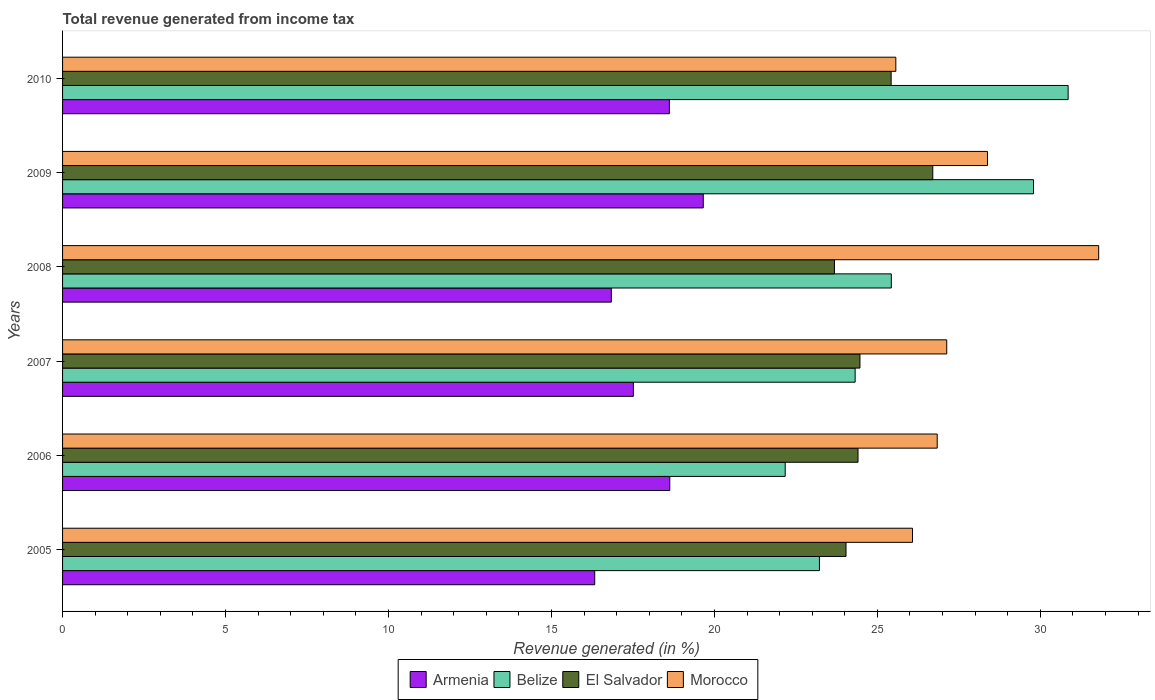How many groups of bars are there?
Offer a terse response. 6. Are the number of bars per tick equal to the number of legend labels?
Keep it short and to the point. Yes. How many bars are there on the 1st tick from the top?
Provide a short and direct response. 4. How many bars are there on the 6th tick from the bottom?
Make the answer very short. 4. In how many cases, is the number of bars for a given year not equal to the number of legend labels?
Make the answer very short. 0. What is the total revenue generated in Belize in 2006?
Make the answer very short. 22.17. Across all years, what is the maximum total revenue generated in Morocco?
Your answer should be very brief. 31.79. Across all years, what is the minimum total revenue generated in Armenia?
Your response must be concise. 16.33. In which year was the total revenue generated in El Salvador maximum?
Give a very brief answer. 2009. What is the total total revenue generated in Belize in the graph?
Provide a succinct answer. 155.78. What is the difference between the total revenue generated in Belize in 2006 and that in 2009?
Offer a terse response. -7.62. What is the difference between the total revenue generated in Morocco in 2009 and the total revenue generated in Belize in 2007?
Provide a succinct answer. 4.06. What is the average total revenue generated in El Salvador per year?
Keep it short and to the point. 24.79. In the year 2005, what is the difference between the total revenue generated in El Salvador and total revenue generated in Morocco?
Offer a very short reply. -2.04. In how many years, is the total revenue generated in El Salvador greater than 3 %?
Give a very brief answer. 6. What is the ratio of the total revenue generated in Belize in 2007 to that in 2010?
Your answer should be compact. 0.79. Is the difference between the total revenue generated in El Salvador in 2006 and 2007 greater than the difference between the total revenue generated in Morocco in 2006 and 2007?
Keep it short and to the point. Yes. What is the difference between the highest and the second highest total revenue generated in Morocco?
Your answer should be very brief. 3.41. What is the difference between the highest and the lowest total revenue generated in Morocco?
Give a very brief answer. 6.22. In how many years, is the total revenue generated in Morocco greater than the average total revenue generated in Morocco taken over all years?
Provide a succinct answer. 2. Is the sum of the total revenue generated in Armenia in 2008 and 2009 greater than the maximum total revenue generated in El Salvador across all years?
Your response must be concise. Yes. Is it the case that in every year, the sum of the total revenue generated in El Salvador and total revenue generated in Armenia is greater than the sum of total revenue generated in Belize and total revenue generated in Morocco?
Give a very brief answer. No. What does the 2nd bar from the top in 2008 represents?
Keep it short and to the point. El Salvador. What does the 4th bar from the bottom in 2009 represents?
Provide a succinct answer. Morocco. Is it the case that in every year, the sum of the total revenue generated in Morocco and total revenue generated in Belize is greater than the total revenue generated in El Salvador?
Ensure brevity in your answer.  Yes. How many years are there in the graph?
Give a very brief answer. 6. Does the graph contain grids?
Offer a very short reply. No. Where does the legend appear in the graph?
Give a very brief answer. Bottom center. How many legend labels are there?
Provide a short and direct response. 4. What is the title of the graph?
Make the answer very short. Total revenue generated from income tax. What is the label or title of the X-axis?
Ensure brevity in your answer.  Revenue generated (in %). What is the label or title of the Y-axis?
Your response must be concise. Years. What is the Revenue generated (in %) of Armenia in 2005?
Offer a terse response. 16.33. What is the Revenue generated (in %) in Belize in 2005?
Provide a succinct answer. 23.22. What is the Revenue generated (in %) in El Salvador in 2005?
Give a very brief answer. 24.04. What is the Revenue generated (in %) in Morocco in 2005?
Ensure brevity in your answer.  26.08. What is the Revenue generated (in %) in Armenia in 2006?
Provide a short and direct response. 18.63. What is the Revenue generated (in %) of Belize in 2006?
Give a very brief answer. 22.17. What is the Revenue generated (in %) of El Salvador in 2006?
Offer a terse response. 24.41. What is the Revenue generated (in %) in Morocco in 2006?
Give a very brief answer. 26.84. What is the Revenue generated (in %) of Armenia in 2007?
Your answer should be compact. 17.51. What is the Revenue generated (in %) in Belize in 2007?
Make the answer very short. 24.32. What is the Revenue generated (in %) of El Salvador in 2007?
Provide a short and direct response. 24.47. What is the Revenue generated (in %) in Morocco in 2007?
Keep it short and to the point. 27.13. What is the Revenue generated (in %) in Armenia in 2008?
Your answer should be very brief. 16.84. What is the Revenue generated (in %) of Belize in 2008?
Your response must be concise. 25.43. What is the Revenue generated (in %) of El Salvador in 2008?
Make the answer very short. 23.68. What is the Revenue generated (in %) in Morocco in 2008?
Your answer should be very brief. 31.79. What is the Revenue generated (in %) in Armenia in 2009?
Offer a terse response. 19.66. What is the Revenue generated (in %) in Belize in 2009?
Offer a very short reply. 29.79. What is the Revenue generated (in %) in El Salvador in 2009?
Ensure brevity in your answer.  26.7. What is the Revenue generated (in %) in Morocco in 2009?
Provide a succinct answer. 28.38. What is the Revenue generated (in %) of Armenia in 2010?
Give a very brief answer. 18.62. What is the Revenue generated (in %) of Belize in 2010?
Your response must be concise. 30.85. What is the Revenue generated (in %) in El Salvador in 2010?
Provide a succinct answer. 25.42. What is the Revenue generated (in %) of Morocco in 2010?
Give a very brief answer. 25.57. Across all years, what is the maximum Revenue generated (in %) of Armenia?
Ensure brevity in your answer.  19.66. Across all years, what is the maximum Revenue generated (in %) of Belize?
Provide a short and direct response. 30.85. Across all years, what is the maximum Revenue generated (in %) of El Salvador?
Your answer should be very brief. 26.7. Across all years, what is the maximum Revenue generated (in %) in Morocco?
Provide a short and direct response. 31.79. Across all years, what is the minimum Revenue generated (in %) in Armenia?
Ensure brevity in your answer.  16.33. Across all years, what is the minimum Revenue generated (in %) in Belize?
Your answer should be compact. 22.17. Across all years, what is the minimum Revenue generated (in %) of El Salvador?
Your answer should be very brief. 23.68. Across all years, what is the minimum Revenue generated (in %) in Morocco?
Ensure brevity in your answer.  25.57. What is the total Revenue generated (in %) of Armenia in the graph?
Ensure brevity in your answer.  107.59. What is the total Revenue generated (in %) in Belize in the graph?
Your answer should be compact. 155.78. What is the total Revenue generated (in %) in El Salvador in the graph?
Your answer should be very brief. 148.72. What is the total Revenue generated (in %) in Morocco in the graph?
Keep it short and to the point. 165.78. What is the difference between the Revenue generated (in %) of Armenia in 2005 and that in 2006?
Offer a very short reply. -2.3. What is the difference between the Revenue generated (in %) of Belize in 2005 and that in 2006?
Provide a succinct answer. 1.05. What is the difference between the Revenue generated (in %) in El Salvador in 2005 and that in 2006?
Give a very brief answer. -0.37. What is the difference between the Revenue generated (in %) of Morocco in 2005 and that in 2006?
Provide a succinct answer. -0.76. What is the difference between the Revenue generated (in %) in Armenia in 2005 and that in 2007?
Offer a terse response. -1.19. What is the difference between the Revenue generated (in %) of Belize in 2005 and that in 2007?
Provide a short and direct response. -1.1. What is the difference between the Revenue generated (in %) in El Salvador in 2005 and that in 2007?
Your response must be concise. -0.43. What is the difference between the Revenue generated (in %) in Morocco in 2005 and that in 2007?
Keep it short and to the point. -1.05. What is the difference between the Revenue generated (in %) of Armenia in 2005 and that in 2008?
Your response must be concise. -0.51. What is the difference between the Revenue generated (in %) of Belize in 2005 and that in 2008?
Provide a short and direct response. -2.21. What is the difference between the Revenue generated (in %) of El Salvador in 2005 and that in 2008?
Your response must be concise. 0.35. What is the difference between the Revenue generated (in %) of Morocco in 2005 and that in 2008?
Make the answer very short. -5.71. What is the difference between the Revenue generated (in %) of Armenia in 2005 and that in 2009?
Provide a succinct answer. -3.33. What is the difference between the Revenue generated (in %) of Belize in 2005 and that in 2009?
Offer a terse response. -6.57. What is the difference between the Revenue generated (in %) of El Salvador in 2005 and that in 2009?
Keep it short and to the point. -2.66. What is the difference between the Revenue generated (in %) in Morocco in 2005 and that in 2009?
Offer a terse response. -2.3. What is the difference between the Revenue generated (in %) in Armenia in 2005 and that in 2010?
Give a very brief answer. -2.29. What is the difference between the Revenue generated (in %) in Belize in 2005 and that in 2010?
Ensure brevity in your answer.  -7.63. What is the difference between the Revenue generated (in %) in El Salvador in 2005 and that in 2010?
Provide a succinct answer. -1.38. What is the difference between the Revenue generated (in %) in Morocco in 2005 and that in 2010?
Provide a succinct answer. 0.51. What is the difference between the Revenue generated (in %) of Armenia in 2006 and that in 2007?
Your response must be concise. 1.12. What is the difference between the Revenue generated (in %) in Belize in 2006 and that in 2007?
Provide a succinct answer. -2.15. What is the difference between the Revenue generated (in %) in El Salvador in 2006 and that in 2007?
Keep it short and to the point. -0.06. What is the difference between the Revenue generated (in %) in Morocco in 2006 and that in 2007?
Keep it short and to the point. -0.29. What is the difference between the Revenue generated (in %) of Armenia in 2006 and that in 2008?
Provide a short and direct response. 1.79. What is the difference between the Revenue generated (in %) of Belize in 2006 and that in 2008?
Offer a terse response. -3.26. What is the difference between the Revenue generated (in %) of El Salvador in 2006 and that in 2008?
Your answer should be very brief. 0.72. What is the difference between the Revenue generated (in %) of Morocco in 2006 and that in 2008?
Your answer should be compact. -4.95. What is the difference between the Revenue generated (in %) of Armenia in 2006 and that in 2009?
Give a very brief answer. -1.03. What is the difference between the Revenue generated (in %) of Belize in 2006 and that in 2009?
Offer a very short reply. -7.62. What is the difference between the Revenue generated (in %) in El Salvador in 2006 and that in 2009?
Provide a short and direct response. -2.29. What is the difference between the Revenue generated (in %) of Morocco in 2006 and that in 2009?
Keep it short and to the point. -1.54. What is the difference between the Revenue generated (in %) in Armenia in 2006 and that in 2010?
Your answer should be compact. 0.01. What is the difference between the Revenue generated (in %) of Belize in 2006 and that in 2010?
Your response must be concise. -8.68. What is the difference between the Revenue generated (in %) in El Salvador in 2006 and that in 2010?
Provide a succinct answer. -1.02. What is the difference between the Revenue generated (in %) of Morocco in 2006 and that in 2010?
Your answer should be very brief. 1.27. What is the difference between the Revenue generated (in %) of Armenia in 2007 and that in 2008?
Ensure brevity in your answer.  0.68. What is the difference between the Revenue generated (in %) in Belize in 2007 and that in 2008?
Give a very brief answer. -1.11. What is the difference between the Revenue generated (in %) of El Salvador in 2007 and that in 2008?
Your response must be concise. 0.78. What is the difference between the Revenue generated (in %) of Morocco in 2007 and that in 2008?
Make the answer very short. -4.66. What is the difference between the Revenue generated (in %) in Armenia in 2007 and that in 2009?
Offer a very short reply. -2.14. What is the difference between the Revenue generated (in %) of Belize in 2007 and that in 2009?
Keep it short and to the point. -5.47. What is the difference between the Revenue generated (in %) in El Salvador in 2007 and that in 2009?
Your answer should be very brief. -2.23. What is the difference between the Revenue generated (in %) of Morocco in 2007 and that in 2009?
Your answer should be very brief. -1.25. What is the difference between the Revenue generated (in %) in Armenia in 2007 and that in 2010?
Offer a very short reply. -1.1. What is the difference between the Revenue generated (in %) in Belize in 2007 and that in 2010?
Offer a very short reply. -6.53. What is the difference between the Revenue generated (in %) in El Salvador in 2007 and that in 2010?
Offer a very short reply. -0.96. What is the difference between the Revenue generated (in %) of Morocco in 2007 and that in 2010?
Your response must be concise. 1.56. What is the difference between the Revenue generated (in %) in Armenia in 2008 and that in 2009?
Offer a very short reply. -2.82. What is the difference between the Revenue generated (in %) in Belize in 2008 and that in 2009?
Provide a succinct answer. -4.36. What is the difference between the Revenue generated (in %) in El Salvador in 2008 and that in 2009?
Keep it short and to the point. -3.02. What is the difference between the Revenue generated (in %) in Morocco in 2008 and that in 2009?
Your response must be concise. 3.41. What is the difference between the Revenue generated (in %) in Armenia in 2008 and that in 2010?
Make the answer very short. -1.78. What is the difference between the Revenue generated (in %) in Belize in 2008 and that in 2010?
Offer a terse response. -5.43. What is the difference between the Revenue generated (in %) in El Salvador in 2008 and that in 2010?
Your response must be concise. -1.74. What is the difference between the Revenue generated (in %) in Morocco in 2008 and that in 2010?
Provide a succinct answer. 6.22. What is the difference between the Revenue generated (in %) of Armenia in 2009 and that in 2010?
Offer a terse response. 1.04. What is the difference between the Revenue generated (in %) in Belize in 2009 and that in 2010?
Provide a succinct answer. -1.06. What is the difference between the Revenue generated (in %) of El Salvador in 2009 and that in 2010?
Make the answer very short. 1.28. What is the difference between the Revenue generated (in %) of Morocco in 2009 and that in 2010?
Your answer should be very brief. 2.81. What is the difference between the Revenue generated (in %) in Armenia in 2005 and the Revenue generated (in %) in Belize in 2006?
Ensure brevity in your answer.  -5.84. What is the difference between the Revenue generated (in %) in Armenia in 2005 and the Revenue generated (in %) in El Salvador in 2006?
Ensure brevity in your answer.  -8.08. What is the difference between the Revenue generated (in %) of Armenia in 2005 and the Revenue generated (in %) of Morocco in 2006?
Your response must be concise. -10.51. What is the difference between the Revenue generated (in %) of Belize in 2005 and the Revenue generated (in %) of El Salvador in 2006?
Your answer should be very brief. -1.18. What is the difference between the Revenue generated (in %) in Belize in 2005 and the Revenue generated (in %) in Morocco in 2006?
Offer a very short reply. -3.61. What is the difference between the Revenue generated (in %) of El Salvador in 2005 and the Revenue generated (in %) of Morocco in 2006?
Provide a succinct answer. -2.8. What is the difference between the Revenue generated (in %) in Armenia in 2005 and the Revenue generated (in %) in Belize in 2007?
Ensure brevity in your answer.  -7.99. What is the difference between the Revenue generated (in %) of Armenia in 2005 and the Revenue generated (in %) of El Salvador in 2007?
Ensure brevity in your answer.  -8.14. What is the difference between the Revenue generated (in %) of Armenia in 2005 and the Revenue generated (in %) of Morocco in 2007?
Keep it short and to the point. -10.8. What is the difference between the Revenue generated (in %) in Belize in 2005 and the Revenue generated (in %) in El Salvador in 2007?
Offer a very short reply. -1.24. What is the difference between the Revenue generated (in %) of Belize in 2005 and the Revenue generated (in %) of Morocco in 2007?
Ensure brevity in your answer.  -3.91. What is the difference between the Revenue generated (in %) of El Salvador in 2005 and the Revenue generated (in %) of Morocco in 2007?
Give a very brief answer. -3.09. What is the difference between the Revenue generated (in %) of Armenia in 2005 and the Revenue generated (in %) of Belize in 2008?
Provide a short and direct response. -9.1. What is the difference between the Revenue generated (in %) in Armenia in 2005 and the Revenue generated (in %) in El Salvador in 2008?
Your answer should be very brief. -7.36. What is the difference between the Revenue generated (in %) of Armenia in 2005 and the Revenue generated (in %) of Morocco in 2008?
Ensure brevity in your answer.  -15.46. What is the difference between the Revenue generated (in %) of Belize in 2005 and the Revenue generated (in %) of El Salvador in 2008?
Provide a succinct answer. -0.46. What is the difference between the Revenue generated (in %) in Belize in 2005 and the Revenue generated (in %) in Morocco in 2008?
Offer a terse response. -8.57. What is the difference between the Revenue generated (in %) in El Salvador in 2005 and the Revenue generated (in %) in Morocco in 2008?
Your response must be concise. -7.75. What is the difference between the Revenue generated (in %) of Armenia in 2005 and the Revenue generated (in %) of Belize in 2009?
Keep it short and to the point. -13.46. What is the difference between the Revenue generated (in %) of Armenia in 2005 and the Revenue generated (in %) of El Salvador in 2009?
Your response must be concise. -10.37. What is the difference between the Revenue generated (in %) of Armenia in 2005 and the Revenue generated (in %) of Morocco in 2009?
Make the answer very short. -12.05. What is the difference between the Revenue generated (in %) in Belize in 2005 and the Revenue generated (in %) in El Salvador in 2009?
Your answer should be very brief. -3.48. What is the difference between the Revenue generated (in %) in Belize in 2005 and the Revenue generated (in %) in Morocco in 2009?
Make the answer very short. -5.16. What is the difference between the Revenue generated (in %) in El Salvador in 2005 and the Revenue generated (in %) in Morocco in 2009?
Give a very brief answer. -4.34. What is the difference between the Revenue generated (in %) in Armenia in 2005 and the Revenue generated (in %) in Belize in 2010?
Your answer should be compact. -14.53. What is the difference between the Revenue generated (in %) in Armenia in 2005 and the Revenue generated (in %) in El Salvador in 2010?
Offer a terse response. -9.1. What is the difference between the Revenue generated (in %) in Armenia in 2005 and the Revenue generated (in %) in Morocco in 2010?
Make the answer very short. -9.24. What is the difference between the Revenue generated (in %) in Belize in 2005 and the Revenue generated (in %) in El Salvador in 2010?
Make the answer very short. -2.2. What is the difference between the Revenue generated (in %) in Belize in 2005 and the Revenue generated (in %) in Morocco in 2010?
Make the answer very short. -2.34. What is the difference between the Revenue generated (in %) of El Salvador in 2005 and the Revenue generated (in %) of Morocco in 2010?
Your response must be concise. -1.53. What is the difference between the Revenue generated (in %) in Armenia in 2006 and the Revenue generated (in %) in Belize in 2007?
Your answer should be very brief. -5.69. What is the difference between the Revenue generated (in %) of Armenia in 2006 and the Revenue generated (in %) of El Salvador in 2007?
Provide a short and direct response. -5.84. What is the difference between the Revenue generated (in %) in Armenia in 2006 and the Revenue generated (in %) in Morocco in 2007?
Provide a short and direct response. -8.5. What is the difference between the Revenue generated (in %) in Belize in 2006 and the Revenue generated (in %) in El Salvador in 2007?
Provide a short and direct response. -2.29. What is the difference between the Revenue generated (in %) of Belize in 2006 and the Revenue generated (in %) of Morocco in 2007?
Give a very brief answer. -4.96. What is the difference between the Revenue generated (in %) in El Salvador in 2006 and the Revenue generated (in %) in Morocco in 2007?
Make the answer very short. -2.72. What is the difference between the Revenue generated (in %) in Armenia in 2006 and the Revenue generated (in %) in Belize in 2008?
Your response must be concise. -6.8. What is the difference between the Revenue generated (in %) of Armenia in 2006 and the Revenue generated (in %) of El Salvador in 2008?
Your answer should be very brief. -5.05. What is the difference between the Revenue generated (in %) of Armenia in 2006 and the Revenue generated (in %) of Morocco in 2008?
Your answer should be very brief. -13.16. What is the difference between the Revenue generated (in %) in Belize in 2006 and the Revenue generated (in %) in El Salvador in 2008?
Keep it short and to the point. -1.51. What is the difference between the Revenue generated (in %) in Belize in 2006 and the Revenue generated (in %) in Morocco in 2008?
Offer a very short reply. -9.62. What is the difference between the Revenue generated (in %) in El Salvador in 2006 and the Revenue generated (in %) in Morocco in 2008?
Your answer should be compact. -7.38. What is the difference between the Revenue generated (in %) in Armenia in 2006 and the Revenue generated (in %) in Belize in 2009?
Provide a short and direct response. -11.16. What is the difference between the Revenue generated (in %) of Armenia in 2006 and the Revenue generated (in %) of El Salvador in 2009?
Offer a very short reply. -8.07. What is the difference between the Revenue generated (in %) of Armenia in 2006 and the Revenue generated (in %) of Morocco in 2009?
Your response must be concise. -9.75. What is the difference between the Revenue generated (in %) in Belize in 2006 and the Revenue generated (in %) in El Salvador in 2009?
Offer a very short reply. -4.53. What is the difference between the Revenue generated (in %) of Belize in 2006 and the Revenue generated (in %) of Morocco in 2009?
Ensure brevity in your answer.  -6.21. What is the difference between the Revenue generated (in %) of El Salvador in 2006 and the Revenue generated (in %) of Morocco in 2009?
Your response must be concise. -3.97. What is the difference between the Revenue generated (in %) of Armenia in 2006 and the Revenue generated (in %) of Belize in 2010?
Your answer should be very brief. -12.22. What is the difference between the Revenue generated (in %) in Armenia in 2006 and the Revenue generated (in %) in El Salvador in 2010?
Give a very brief answer. -6.79. What is the difference between the Revenue generated (in %) in Armenia in 2006 and the Revenue generated (in %) in Morocco in 2010?
Your answer should be compact. -6.94. What is the difference between the Revenue generated (in %) in Belize in 2006 and the Revenue generated (in %) in El Salvador in 2010?
Offer a terse response. -3.25. What is the difference between the Revenue generated (in %) of Belize in 2006 and the Revenue generated (in %) of Morocco in 2010?
Offer a very short reply. -3.39. What is the difference between the Revenue generated (in %) in El Salvador in 2006 and the Revenue generated (in %) in Morocco in 2010?
Offer a terse response. -1.16. What is the difference between the Revenue generated (in %) in Armenia in 2007 and the Revenue generated (in %) in Belize in 2008?
Your response must be concise. -7.91. What is the difference between the Revenue generated (in %) of Armenia in 2007 and the Revenue generated (in %) of El Salvador in 2008?
Provide a short and direct response. -6.17. What is the difference between the Revenue generated (in %) in Armenia in 2007 and the Revenue generated (in %) in Morocco in 2008?
Your answer should be very brief. -14.28. What is the difference between the Revenue generated (in %) of Belize in 2007 and the Revenue generated (in %) of El Salvador in 2008?
Keep it short and to the point. 0.64. What is the difference between the Revenue generated (in %) of Belize in 2007 and the Revenue generated (in %) of Morocco in 2008?
Your answer should be very brief. -7.47. What is the difference between the Revenue generated (in %) of El Salvador in 2007 and the Revenue generated (in %) of Morocco in 2008?
Provide a short and direct response. -7.32. What is the difference between the Revenue generated (in %) in Armenia in 2007 and the Revenue generated (in %) in Belize in 2009?
Your answer should be very brief. -12.28. What is the difference between the Revenue generated (in %) in Armenia in 2007 and the Revenue generated (in %) in El Salvador in 2009?
Keep it short and to the point. -9.19. What is the difference between the Revenue generated (in %) in Armenia in 2007 and the Revenue generated (in %) in Morocco in 2009?
Provide a short and direct response. -10.86. What is the difference between the Revenue generated (in %) in Belize in 2007 and the Revenue generated (in %) in El Salvador in 2009?
Ensure brevity in your answer.  -2.38. What is the difference between the Revenue generated (in %) in Belize in 2007 and the Revenue generated (in %) in Morocco in 2009?
Offer a very short reply. -4.06. What is the difference between the Revenue generated (in %) in El Salvador in 2007 and the Revenue generated (in %) in Morocco in 2009?
Your answer should be compact. -3.91. What is the difference between the Revenue generated (in %) of Armenia in 2007 and the Revenue generated (in %) of Belize in 2010?
Provide a short and direct response. -13.34. What is the difference between the Revenue generated (in %) of Armenia in 2007 and the Revenue generated (in %) of El Salvador in 2010?
Provide a short and direct response. -7.91. What is the difference between the Revenue generated (in %) of Armenia in 2007 and the Revenue generated (in %) of Morocco in 2010?
Your answer should be compact. -8.05. What is the difference between the Revenue generated (in %) in Belize in 2007 and the Revenue generated (in %) in El Salvador in 2010?
Keep it short and to the point. -1.1. What is the difference between the Revenue generated (in %) of Belize in 2007 and the Revenue generated (in %) of Morocco in 2010?
Your response must be concise. -1.25. What is the difference between the Revenue generated (in %) in El Salvador in 2007 and the Revenue generated (in %) in Morocco in 2010?
Make the answer very short. -1.1. What is the difference between the Revenue generated (in %) of Armenia in 2008 and the Revenue generated (in %) of Belize in 2009?
Offer a terse response. -12.95. What is the difference between the Revenue generated (in %) of Armenia in 2008 and the Revenue generated (in %) of El Salvador in 2009?
Your answer should be compact. -9.86. What is the difference between the Revenue generated (in %) in Armenia in 2008 and the Revenue generated (in %) in Morocco in 2009?
Give a very brief answer. -11.54. What is the difference between the Revenue generated (in %) in Belize in 2008 and the Revenue generated (in %) in El Salvador in 2009?
Keep it short and to the point. -1.27. What is the difference between the Revenue generated (in %) in Belize in 2008 and the Revenue generated (in %) in Morocco in 2009?
Give a very brief answer. -2.95. What is the difference between the Revenue generated (in %) of El Salvador in 2008 and the Revenue generated (in %) of Morocco in 2009?
Ensure brevity in your answer.  -4.7. What is the difference between the Revenue generated (in %) in Armenia in 2008 and the Revenue generated (in %) in Belize in 2010?
Provide a short and direct response. -14.02. What is the difference between the Revenue generated (in %) in Armenia in 2008 and the Revenue generated (in %) in El Salvador in 2010?
Keep it short and to the point. -8.59. What is the difference between the Revenue generated (in %) in Armenia in 2008 and the Revenue generated (in %) in Morocco in 2010?
Ensure brevity in your answer.  -8.73. What is the difference between the Revenue generated (in %) in Belize in 2008 and the Revenue generated (in %) in El Salvador in 2010?
Make the answer very short. 0.01. What is the difference between the Revenue generated (in %) of Belize in 2008 and the Revenue generated (in %) of Morocco in 2010?
Your answer should be very brief. -0.14. What is the difference between the Revenue generated (in %) in El Salvador in 2008 and the Revenue generated (in %) in Morocco in 2010?
Your response must be concise. -1.88. What is the difference between the Revenue generated (in %) in Armenia in 2009 and the Revenue generated (in %) in Belize in 2010?
Provide a succinct answer. -11.19. What is the difference between the Revenue generated (in %) in Armenia in 2009 and the Revenue generated (in %) in El Salvador in 2010?
Ensure brevity in your answer.  -5.76. What is the difference between the Revenue generated (in %) of Armenia in 2009 and the Revenue generated (in %) of Morocco in 2010?
Your answer should be very brief. -5.91. What is the difference between the Revenue generated (in %) of Belize in 2009 and the Revenue generated (in %) of El Salvador in 2010?
Offer a very short reply. 4.37. What is the difference between the Revenue generated (in %) in Belize in 2009 and the Revenue generated (in %) in Morocco in 2010?
Ensure brevity in your answer.  4.22. What is the difference between the Revenue generated (in %) of El Salvador in 2009 and the Revenue generated (in %) of Morocco in 2010?
Give a very brief answer. 1.13. What is the average Revenue generated (in %) of Armenia per year?
Your response must be concise. 17.93. What is the average Revenue generated (in %) of Belize per year?
Keep it short and to the point. 25.96. What is the average Revenue generated (in %) of El Salvador per year?
Your response must be concise. 24.79. What is the average Revenue generated (in %) of Morocco per year?
Offer a terse response. 27.63. In the year 2005, what is the difference between the Revenue generated (in %) of Armenia and Revenue generated (in %) of Belize?
Give a very brief answer. -6.89. In the year 2005, what is the difference between the Revenue generated (in %) of Armenia and Revenue generated (in %) of El Salvador?
Keep it short and to the point. -7.71. In the year 2005, what is the difference between the Revenue generated (in %) in Armenia and Revenue generated (in %) in Morocco?
Ensure brevity in your answer.  -9.75. In the year 2005, what is the difference between the Revenue generated (in %) of Belize and Revenue generated (in %) of El Salvador?
Offer a very short reply. -0.82. In the year 2005, what is the difference between the Revenue generated (in %) of Belize and Revenue generated (in %) of Morocco?
Make the answer very short. -2.86. In the year 2005, what is the difference between the Revenue generated (in %) of El Salvador and Revenue generated (in %) of Morocco?
Provide a short and direct response. -2.04. In the year 2006, what is the difference between the Revenue generated (in %) in Armenia and Revenue generated (in %) in Belize?
Your answer should be compact. -3.54. In the year 2006, what is the difference between the Revenue generated (in %) of Armenia and Revenue generated (in %) of El Salvador?
Keep it short and to the point. -5.78. In the year 2006, what is the difference between the Revenue generated (in %) in Armenia and Revenue generated (in %) in Morocco?
Provide a succinct answer. -8.21. In the year 2006, what is the difference between the Revenue generated (in %) in Belize and Revenue generated (in %) in El Salvador?
Your answer should be compact. -2.23. In the year 2006, what is the difference between the Revenue generated (in %) of Belize and Revenue generated (in %) of Morocco?
Give a very brief answer. -4.66. In the year 2006, what is the difference between the Revenue generated (in %) of El Salvador and Revenue generated (in %) of Morocco?
Make the answer very short. -2.43. In the year 2007, what is the difference between the Revenue generated (in %) of Armenia and Revenue generated (in %) of Belize?
Give a very brief answer. -6.8. In the year 2007, what is the difference between the Revenue generated (in %) in Armenia and Revenue generated (in %) in El Salvador?
Provide a short and direct response. -6.95. In the year 2007, what is the difference between the Revenue generated (in %) of Armenia and Revenue generated (in %) of Morocco?
Provide a short and direct response. -9.61. In the year 2007, what is the difference between the Revenue generated (in %) in Belize and Revenue generated (in %) in El Salvador?
Offer a very short reply. -0.15. In the year 2007, what is the difference between the Revenue generated (in %) in Belize and Revenue generated (in %) in Morocco?
Give a very brief answer. -2.81. In the year 2007, what is the difference between the Revenue generated (in %) of El Salvador and Revenue generated (in %) of Morocco?
Provide a succinct answer. -2.66. In the year 2008, what is the difference between the Revenue generated (in %) of Armenia and Revenue generated (in %) of Belize?
Provide a short and direct response. -8.59. In the year 2008, what is the difference between the Revenue generated (in %) in Armenia and Revenue generated (in %) in El Salvador?
Ensure brevity in your answer.  -6.85. In the year 2008, what is the difference between the Revenue generated (in %) of Armenia and Revenue generated (in %) of Morocco?
Keep it short and to the point. -14.95. In the year 2008, what is the difference between the Revenue generated (in %) in Belize and Revenue generated (in %) in El Salvador?
Your response must be concise. 1.74. In the year 2008, what is the difference between the Revenue generated (in %) of Belize and Revenue generated (in %) of Morocco?
Keep it short and to the point. -6.36. In the year 2008, what is the difference between the Revenue generated (in %) of El Salvador and Revenue generated (in %) of Morocco?
Offer a very short reply. -8.11. In the year 2009, what is the difference between the Revenue generated (in %) in Armenia and Revenue generated (in %) in Belize?
Your response must be concise. -10.13. In the year 2009, what is the difference between the Revenue generated (in %) of Armenia and Revenue generated (in %) of El Salvador?
Make the answer very short. -7.04. In the year 2009, what is the difference between the Revenue generated (in %) of Armenia and Revenue generated (in %) of Morocco?
Offer a terse response. -8.72. In the year 2009, what is the difference between the Revenue generated (in %) of Belize and Revenue generated (in %) of El Salvador?
Your answer should be very brief. 3.09. In the year 2009, what is the difference between the Revenue generated (in %) of Belize and Revenue generated (in %) of Morocco?
Your response must be concise. 1.41. In the year 2009, what is the difference between the Revenue generated (in %) in El Salvador and Revenue generated (in %) in Morocco?
Offer a very short reply. -1.68. In the year 2010, what is the difference between the Revenue generated (in %) in Armenia and Revenue generated (in %) in Belize?
Your response must be concise. -12.23. In the year 2010, what is the difference between the Revenue generated (in %) in Armenia and Revenue generated (in %) in El Salvador?
Your response must be concise. -6.8. In the year 2010, what is the difference between the Revenue generated (in %) in Armenia and Revenue generated (in %) in Morocco?
Provide a succinct answer. -6.95. In the year 2010, what is the difference between the Revenue generated (in %) of Belize and Revenue generated (in %) of El Salvador?
Keep it short and to the point. 5.43. In the year 2010, what is the difference between the Revenue generated (in %) in Belize and Revenue generated (in %) in Morocco?
Offer a very short reply. 5.29. In the year 2010, what is the difference between the Revenue generated (in %) of El Salvador and Revenue generated (in %) of Morocco?
Provide a short and direct response. -0.14. What is the ratio of the Revenue generated (in %) in Armenia in 2005 to that in 2006?
Provide a short and direct response. 0.88. What is the ratio of the Revenue generated (in %) of Belize in 2005 to that in 2006?
Ensure brevity in your answer.  1.05. What is the ratio of the Revenue generated (in %) of El Salvador in 2005 to that in 2006?
Offer a terse response. 0.98. What is the ratio of the Revenue generated (in %) in Morocco in 2005 to that in 2006?
Your response must be concise. 0.97. What is the ratio of the Revenue generated (in %) of Armenia in 2005 to that in 2007?
Give a very brief answer. 0.93. What is the ratio of the Revenue generated (in %) of Belize in 2005 to that in 2007?
Offer a very short reply. 0.95. What is the ratio of the Revenue generated (in %) in El Salvador in 2005 to that in 2007?
Ensure brevity in your answer.  0.98. What is the ratio of the Revenue generated (in %) in Morocco in 2005 to that in 2007?
Your answer should be compact. 0.96. What is the ratio of the Revenue generated (in %) of Armenia in 2005 to that in 2008?
Your answer should be very brief. 0.97. What is the ratio of the Revenue generated (in %) in Belize in 2005 to that in 2008?
Keep it short and to the point. 0.91. What is the ratio of the Revenue generated (in %) in Morocco in 2005 to that in 2008?
Ensure brevity in your answer.  0.82. What is the ratio of the Revenue generated (in %) of Armenia in 2005 to that in 2009?
Give a very brief answer. 0.83. What is the ratio of the Revenue generated (in %) in Belize in 2005 to that in 2009?
Offer a very short reply. 0.78. What is the ratio of the Revenue generated (in %) of El Salvador in 2005 to that in 2009?
Offer a terse response. 0.9. What is the ratio of the Revenue generated (in %) in Morocco in 2005 to that in 2009?
Provide a succinct answer. 0.92. What is the ratio of the Revenue generated (in %) in Armenia in 2005 to that in 2010?
Your response must be concise. 0.88. What is the ratio of the Revenue generated (in %) of Belize in 2005 to that in 2010?
Your answer should be compact. 0.75. What is the ratio of the Revenue generated (in %) in El Salvador in 2005 to that in 2010?
Your answer should be very brief. 0.95. What is the ratio of the Revenue generated (in %) of Morocco in 2005 to that in 2010?
Your answer should be very brief. 1.02. What is the ratio of the Revenue generated (in %) of Armenia in 2006 to that in 2007?
Make the answer very short. 1.06. What is the ratio of the Revenue generated (in %) of Belize in 2006 to that in 2007?
Your response must be concise. 0.91. What is the ratio of the Revenue generated (in %) of El Salvador in 2006 to that in 2007?
Your answer should be very brief. 1. What is the ratio of the Revenue generated (in %) of Armenia in 2006 to that in 2008?
Give a very brief answer. 1.11. What is the ratio of the Revenue generated (in %) in Belize in 2006 to that in 2008?
Make the answer very short. 0.87. What is the ratio of the Revenue generated (in %) of El Salvador in 2006 to that in 2008?
Make the answer very short. 1.03. What is the ratio of the Revenue generated (in %) of Morocco in 2006 to that in 2008?
Ensure brevity in your answer.  0.84. What is the ratio of the Revenue generated (in %) of Armenia in 2006 to that in 2009?
Provide a succinct answer. 0.95. What is the ratio of the Revenue generated (in %) in Belize in 2006 to that in 2009?
Give a very brief answer. 0.74. What is the ratio of the Revenue generated (in %) in El Salvador in 2006 to that in 2009?
Ensure brevity in your answer.  0.91. What is the ratio of the Revenue generated (in %) of Morocco in 2006 to that in 2009?
Offer a terse response. 0.95. What is the ratio of the Revenue generated (in %) in Armenia in 2006 to that in 2010?
Ensure brevity in your answer.  1. What is the ratio of the Revenue generated (in %) in Belize in 2006 to that in 2010?
Ensure brevity in your answer.  0.72. What is the ratio of the Revenue generated (in %) of El Salvador in 2006 to that in 2010?
Keep it short and to the point. 0.96. What is the ratio of the Revenue generated (in %) in Morocco in 2006 to that in 2010?
Give a very brief answer. 1.05. What is the ratio of the Revenue generated (in %) in Armenia in 2007 to that in 2008?
Offer a very short reply. 1.04. What is the ratio of the Revenue generated (in %) of Belize in 2007 to that in 2008?
Your response must be concise. 0.96. What is the ratio of the Revenue generated (in %) in El Salvador in 2007 to that in 2008?
Offer a terse response. 1.03. What is the ratio of the Revenue generated (in %) in Morocco in 2007 to that in 2008?
Provide a short and direct response. 0.85. What is the ratio of the Revenue generated (in %) in Armenia in 2007 to that in 2009?
Your answer should be very brief. 0.89. What is the ratio of the Revenue generated (in %) in Belize in 2007 to that in 2009?
Give a very brief answer. 0.82. What is the ratio of the Revenue generated (in %) in El Salvador in 2007 to that in 2009?
Ensure brevity in your answer.  0.92. What is the ratio of the Revenue generated (in %) of Morocco in 2007 to that in 2009?
Provide a short and direct response. 0.96. What is the ratio of the Revenue generated (in %) of Armenia in 2007 to that in 2010?
Provide a succinct answer. 0.94. What is the ratio of the Revenue generated (in %) of Belize in 2007 to that in 2010?
Offer a terse response. 0.79. What is the ratio of the Revenue generated (in %) in El Salvador in 2007 to that in 2010?
Your response must be concise. 0.96. What is the ratio of the Revenue generated (in %) of Morocco in 2007 to that in 2010?
Ensure brevity in your answer.  1.06. What is the ratio of the Revenue generated (in %) in Armenia in 2008 to that in 2009?
Give a very brief answer. 0.86. What is the ratio of the Revenue generated (in %) of Belize in 2008 to that in 2009?
Ensure brevity in your answer.  0.85. What is the ratio of the Revenue generated (in %) of El Salvador in 2008 to that in 2009?
Your answer should be compact. 0.89. What is the ratio of the Revenue generated (in %) in Morocco in 2008 to that in 2009?
Keep it short and to the point. 1.12. What is the ratio of the Revenue generated (in %) in Armenia in 2008 to that in 2010?
Your response must be concise. 0.9. What is the ratio of the Revenue generated (in %) in Belize in 2008 to that in 2010?
Offer a very short reply. 0.82. What is the ratio of the Revenue generated (in %) in El Salvador in 2008 to that in 2010?
Ensure brevity in your answer.  0.93. What is the ratio of the Revenue generated (in %) of Morocco in 2008 to that in 2010?
Make the answer very short. 1.24. What is the ratio of the Revenue generated (in %) of Armenia in 2009 to that in 2010?
Provide a short and direct response. 1.06. What is the ratio of the Revenue generated (in %) of Belize in 2009 to that in 2010?
Your answer should be compact. 0.97. What is the ratio of the Revenue generated (in %) of El Salvador in 2009 to that in 2010?
Offer a very short reply. 1.05. What is the ratio of the Revenue generated (in %) in Morocco in 2009 to that in 2010?
Give a very brief answer. 1.11. What is the difference between the highest and the second highest Revenue generated (in %) of Armenia?
Provide a succinct answer. 1.03. What is the difference between the highest and the second highest Revenue generated (in %) of Belize?
Provide a short and direct response. 1.06. What is the difference between the highest and the second highest Revenue generated (in %) in El Salvador?
Offer a very short reply. 1.28. What is the difference between the highest and the second highest Revenue generated (in %) in Morocco?
Offer a very short reply. 3.41. What is the difference between the highest and the lowest Revenue generated (in %) of Armenia?
Provide a short and direct response. 3.33. What is the difference between the highest and the lowest Revenue generated (in %) of Belize?
Offer a very short reply. 8.68. What is the difference between the highest and the lowest Revenue generated (in %) of El Salvador?
Offer a terse response. 3.02. What is the difference between the highest and the lowest Revenue generated (in %) in Morocco?
Offer a very short reply. 6.22. 